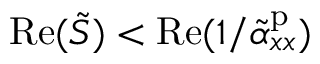<formula> <loc_0><loc_0><loc_500><loc_500>R e ( \tilde { S } ) < R e ( 1 / \tilde { \alpha } _ { x x } ^ { p } )</formula> 